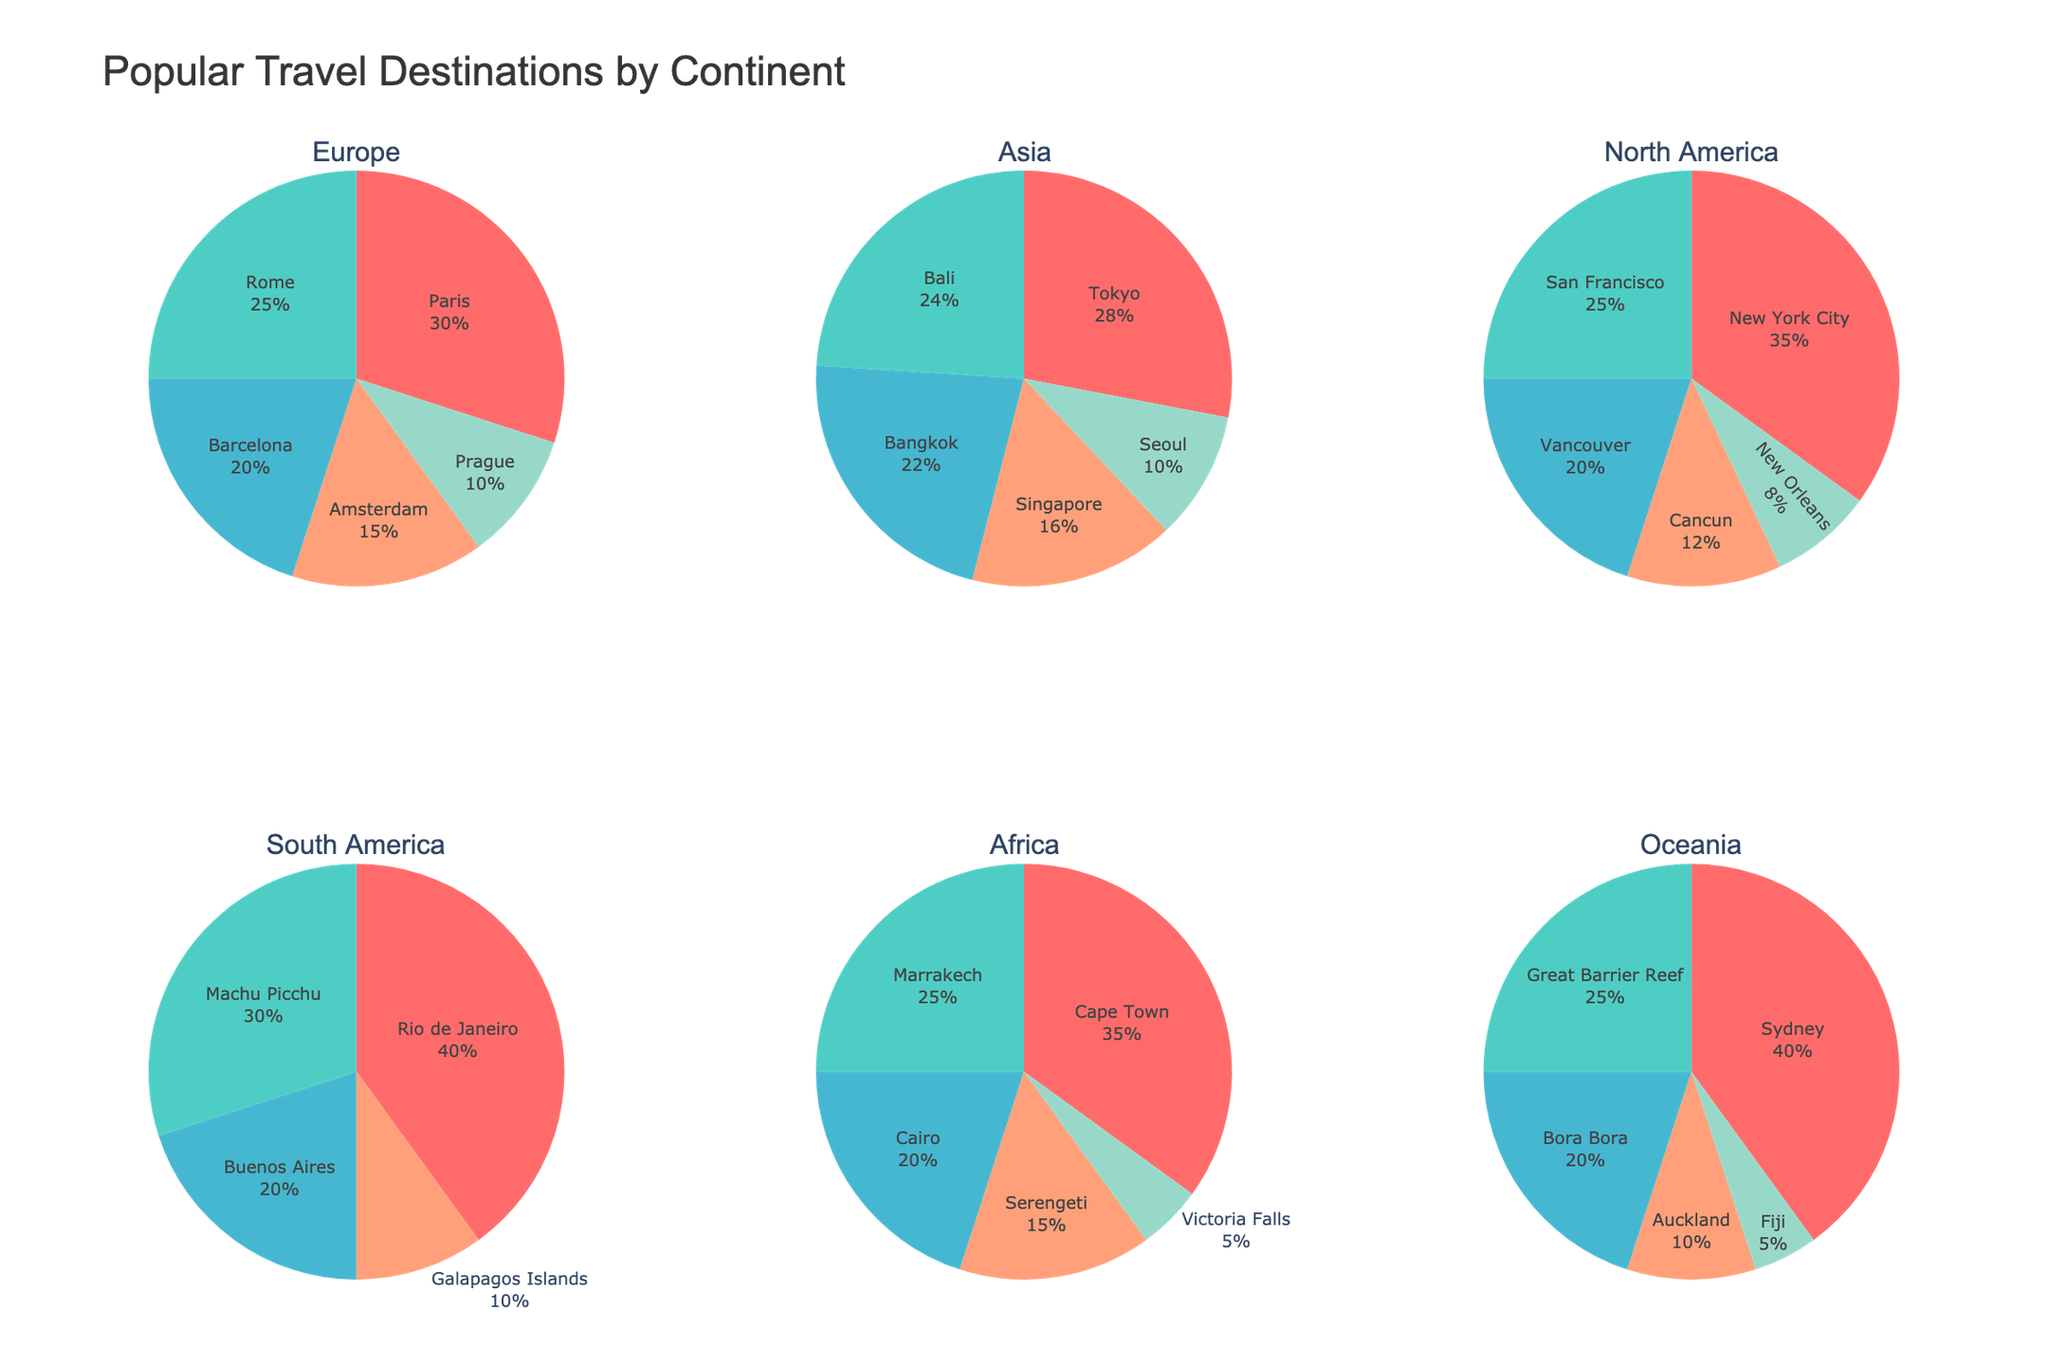what is the title of the figure? The title is displayed at the top of the chart, generally in a bold or larger font size. The provided code sets the title as "Popular Travel Destinations by Continent".
Answer: Popular Travel Destinations by Continent how many continents are represented in the figure? Each pie chart represents a different continent. There are six subplots or pie charts, hence there are six continents.
Answer: 6 which destination has the highest percentage in Europe? By looking at the pie chart for Europe, we can observe that Paris has the largest slice, indicating that it has the highest percentage.
Answer: Paris what’s the combined percentage of Tokyo and Bali in Asia? The percentages for Tokyo and Bali are 28% and 24%, respectively. Adding them together gives 28% + 24% = 52%.
Answer: 52% how do the percentages of New York City and San Francisco in North America compare? In the pie chart for North America, New York City has a percentage of 35% while San Francisco has 25%. New York City's percentage is higher than San Francisco's.
Answer: New York City has 10% more which African destination has the lowest percentage? In the pie chart for Africa, the smallest slice represents Victoria Falls, which has the lowest percentage.
Answer: Victoria Falls order the South American destinations by percentage from highest to lowest. Looking at the pie chart for South America, the destinations can be listed from highest to lowest as follows: Rio de Janeiro (40%), Machu Picchu (30%), Buenos Aires (20%), Galapagos Islands (10%).
Answer: Rio de Janeiro, Machu Picchu, Buenos Aires, Galapagos Islands if you combine the percentages of Bangkok and Singapore in Asia, is it higher than Bali’s percentage in Oceania? The percentages of Bangkok and Singapore are 22% and 16%, respectively, making their combined percentage 22% + 16% = 38%. Bali’s percentage is 24%, which is less than 38%.
Answer: Yes which continent has Sydney as one of its destinations, and what’s its percentage? Sydney is visible in the pie chart for Oceania, where it has the largest slice at 40%.
Answer: Oceania, 40% how many destinations have a percentage of 10% in their respective continents? The destinations with a 10% slice in their respective continents are Prague (Europe), Seoul (Asia), New Orleans (North America), Galapagos Islands (South America), Auckland (Oceania). Total count is 5.
Answer: 5 